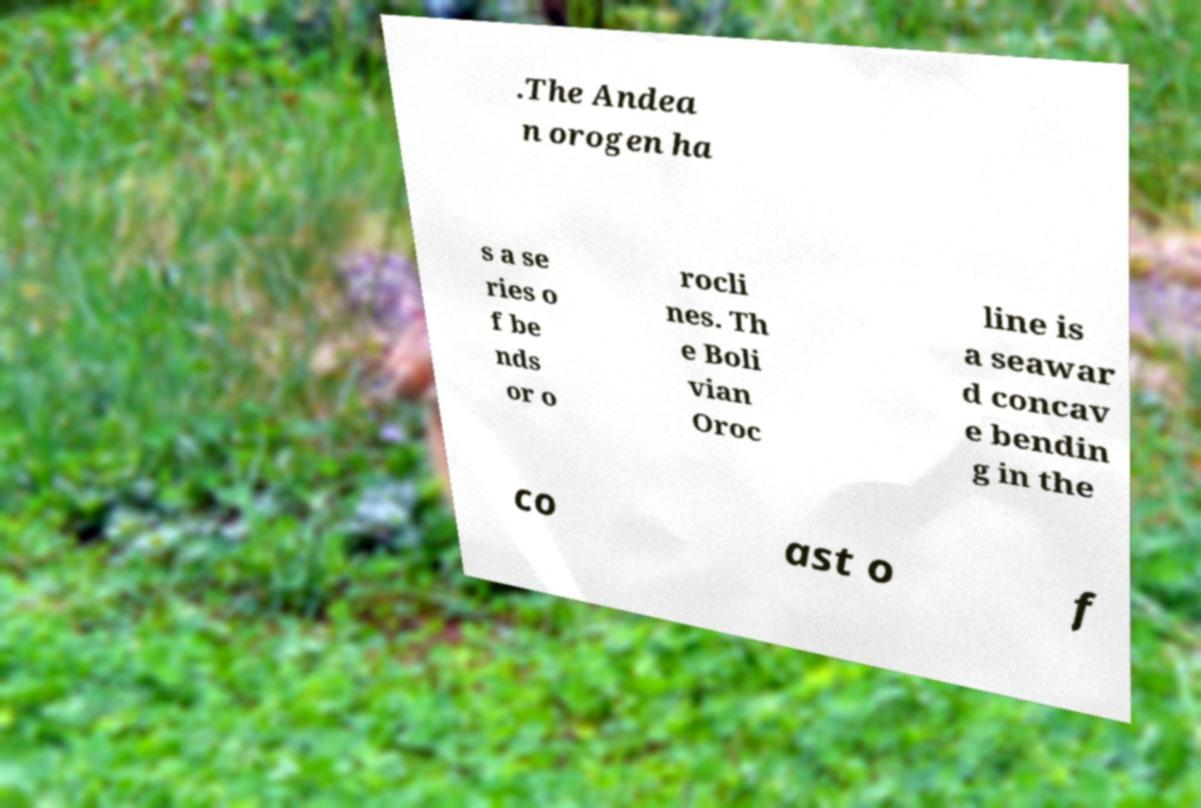For documentation purposes, I need the text within this image transcribed. Could you provide that? .The Andea n orogen ha s a se ries o f be nds or o rocli nes. Th e Boli vian Oroc line is a seawar d concav e bendin g in the co ast o f 